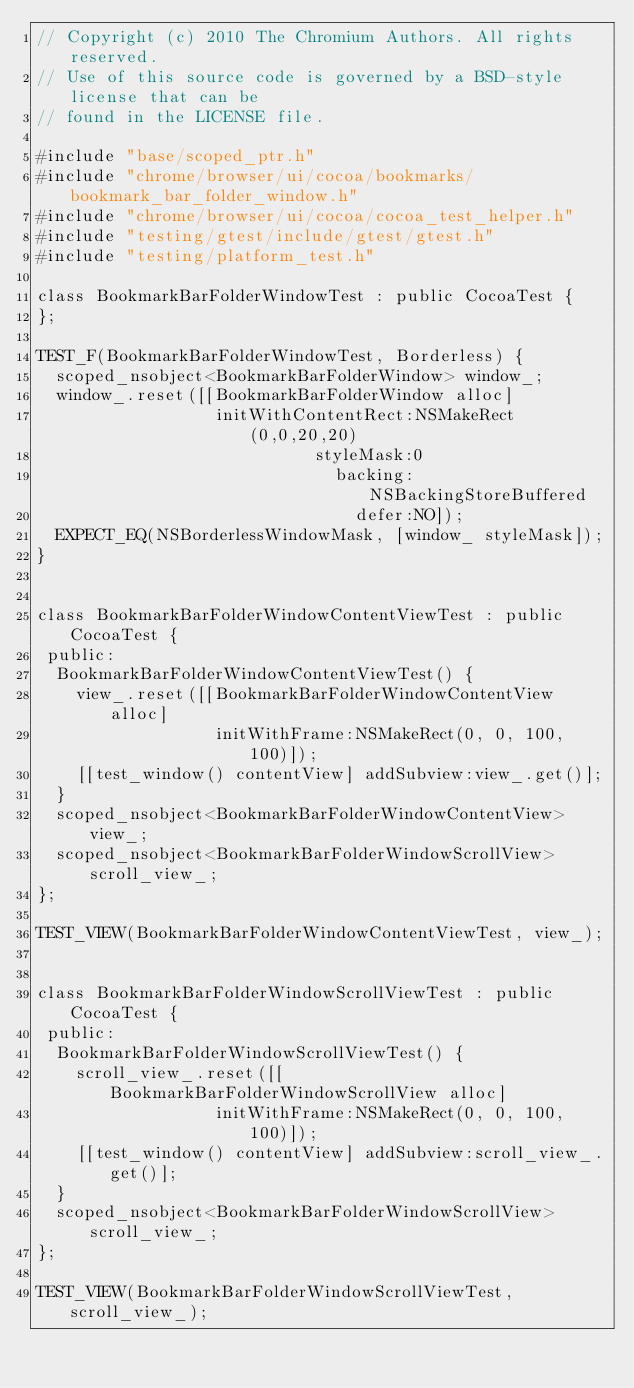<code> <loc_0><loc_0><loc_500><loc_500><_ObjectiveC_>// Copyright (c) 2010 The Chromium Authors. All rights reserved.
// Use of this source code is governed by a BSD-style license that can be
// found in the LICENSE file.

#include "base/scoped_ptr.h"
#include "chrome/browser/ui/cocoa/bookmarks/bookmark_bar_folder_window.h"
#include "chrome/browser/ui/cocoa/cocoa_test_helper.h"
#include "testing/gtest/include/gtest/gtest.h"
#include "testing/platform_test.h"

class BookmarkBarFolderWindowTest : public CocoaTest {
};

TEST_F(BookmarkBarFolderWindowTest, Borderless) {
  scoped_nsobject<BookmarkBarFolderWindow> window_;
  window_.reset([[BookmarkBarFolderWindow alloc]
                  initWithContentRect:NSMakeRect(0,0,20,20)
                            styleMask:0
                              backing:NSBackingStoreBuffered
                                defer:NO]);
  EXPECT_EQ(NSBorderlessWindowMask, [window_ styleMask]);
}


class BookmarkBarFolderWindowContentViewTest : public CocoaTest {
 public:
  BookmarkBarFolderWindowContentViewTest() {
    view_.reset([[BookmarkBarFolderWindowContentView alloc]
                  initWithFrame:NSMakeRect(0, 0, 100, 100)]);
    [[test_window() contentView] addSubview:view_.get()];
  }
  scoped_nsobject<BookmarkBarFolderWindowContentView> view_;
  scoped_nsobject<BookmarkBarFolderWindowScrollView> scroll_view_;
};

TEST_VIEW(BookmarkBarFolderWindowContentViewTest, view_);


class BookmarkBarFolderWindowScrollViewTest : public CocoaTest {
 public:
  BookmarkBarFolderWindowScrollViewTest() {
    scroll_view_.reset([[BookmarkBarFolderWindowScrollView alloc]
                  initWithFrame:NSMakeRect(0, 0, 100, 100)]);
    [[test_window() contentView] addSubview:scroll_view_.get()];
  }
  scoped_nsobject<BookmarkBarFolderWindowScrollView> scroll_view_;
};

TEST_VIEW(BookmarkBarFolderWindowScrollViewTest, scroll_view_);
</code> 